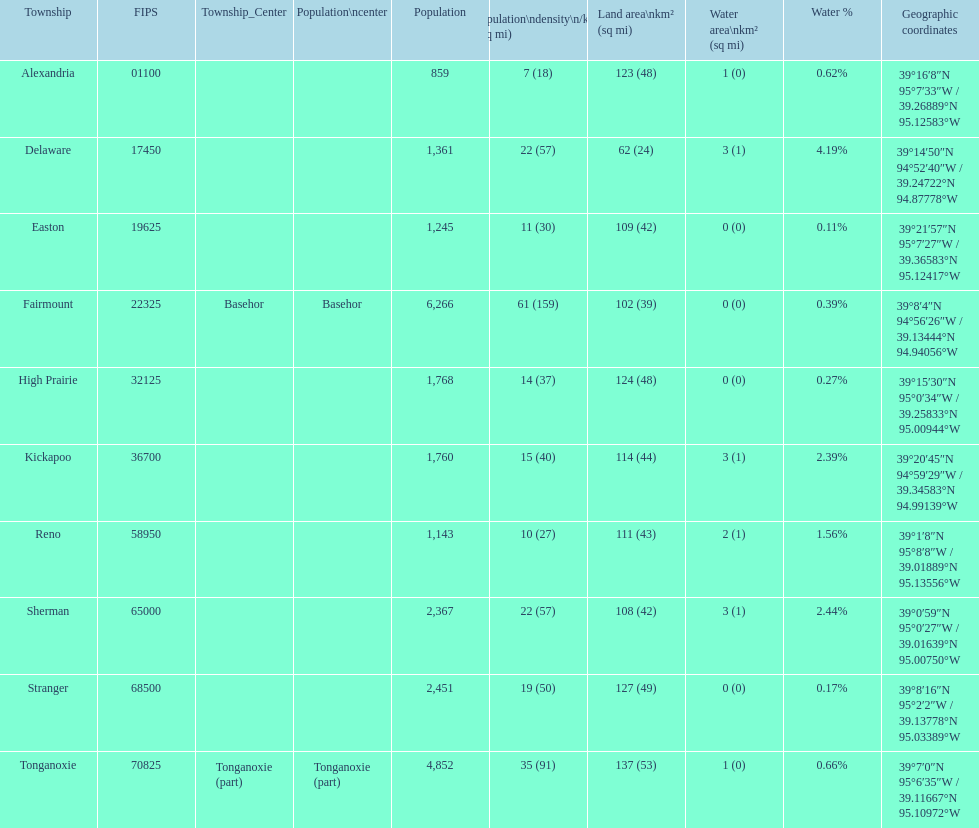What is the number of townships with a population larger than 2,000? 4. 